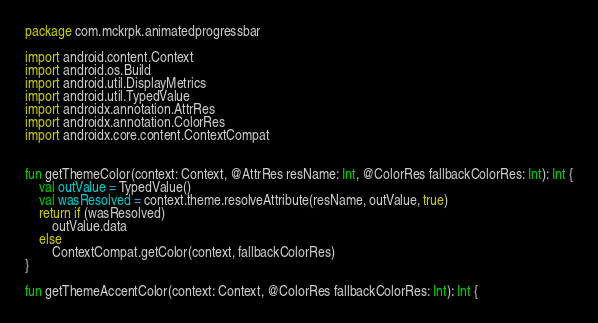Convert code to text. <code><loc_0><loc_0><loc_500><loc_500><_Kotlin_>package com.mckrpk.animatedprogressbar

import android.content.Context
import android.os.Build
import android.util.DisplayMetrics
import android.util.TypedValue
import androidx.annotation.AttrRes
import androidx.annotation.ColorRes
import androidx.core.content.ContextCompat


fun getThemeColor(context: Context, @AttrRes resName: Int, @ColorRes fallbackColorRes: Int): Int {
    val outValue = TypedValue()
    val wasResolved = context.theme.resolveAttribute(resName, outValue, true)
    return if (wasResolved)
        outValue.data
    else
        ContextCompat.getColor(context, fallbackColorRes)
}

fun getThemeAccentColor(context: Context, @ColorRes fallbackColorRes: Int): Int {</code> 